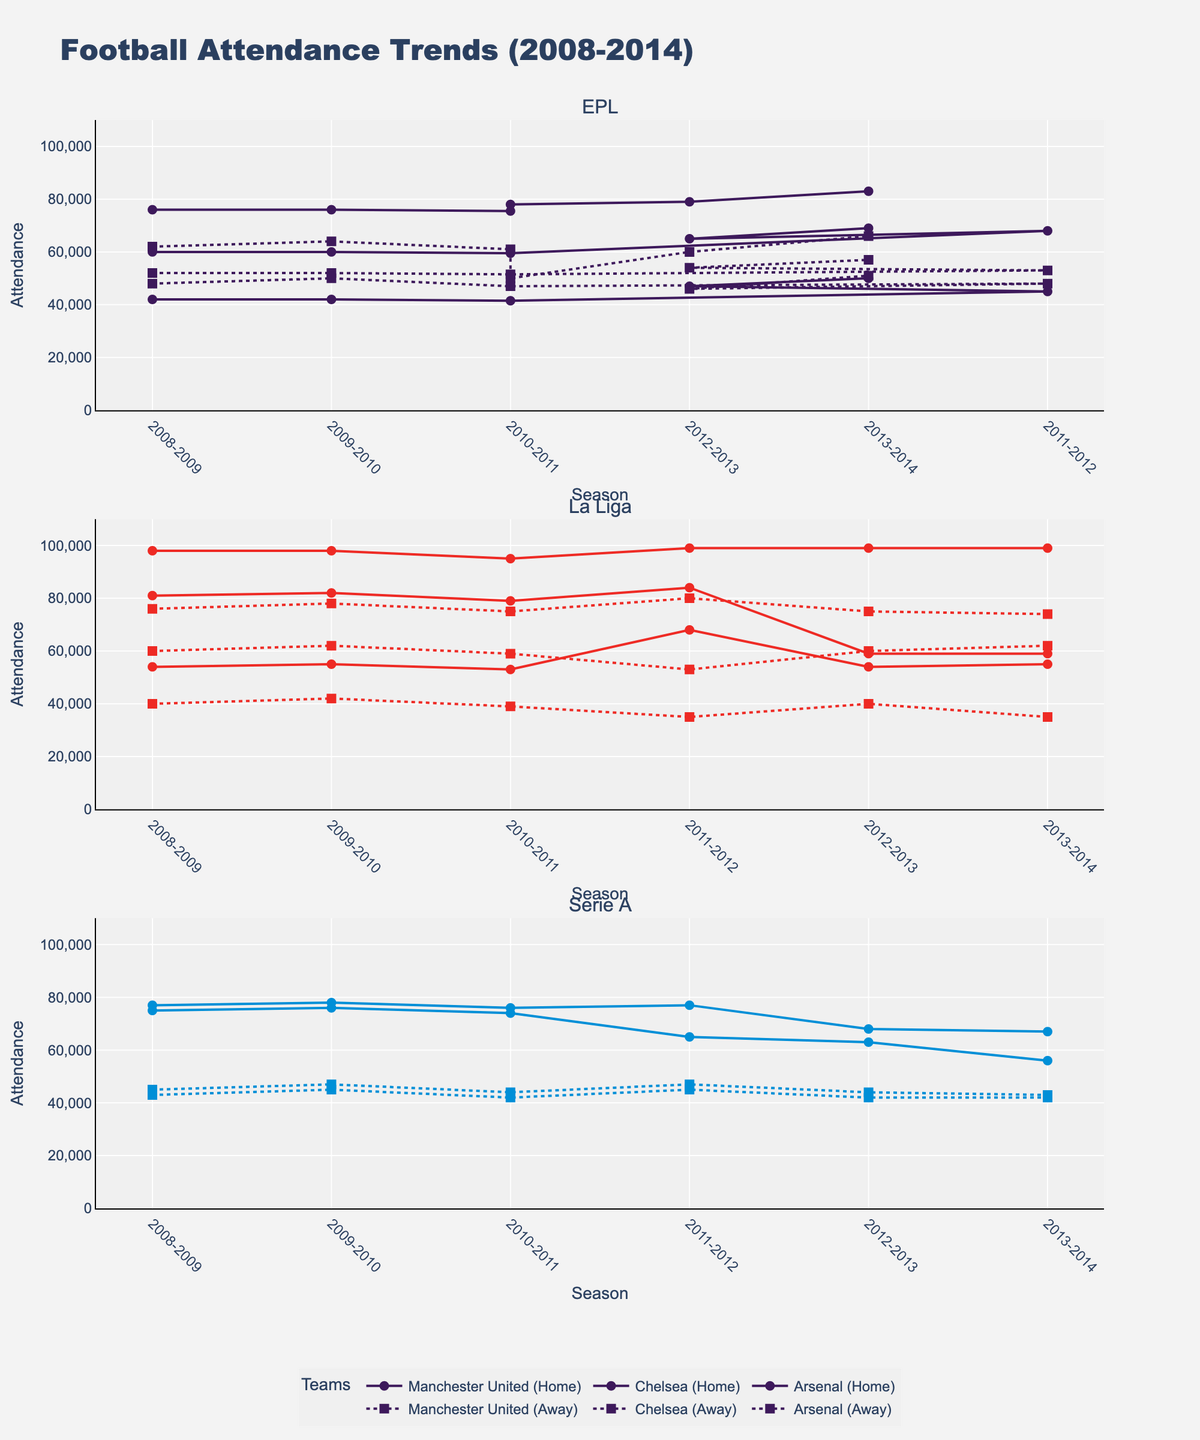What are the subplot titles in the figure? The subplot titles represent the three major European football leagues shown in the plot. They are the English Premier League (EPL), La Liga, and Serie A. Each subplot displays data specific to one league.
Answer: EPL, La Liga, Serie A What is the overall title of the figure? The overall title gives a general idea of what the figure is about, describing the trends in football attendance over the given period and for the specified leagues.
Answer: Football Attendance Trends (2008-2014) Which team had the highest home attendance in the 2011-2012 season for La Liga? By focusing on the La Liga subplot and looking at the year 2011-2012, identify which team's home attendance line peaks the highest out of all the La Liga teams. Barcelona has the highest home attendance.
Answer: Barcelona How did the away attendance of Manchester United change from the 2008-2009 season to the 2013-2014 season? Manchester United (Away) is represented by a line with markers in the EPL subplot. Comparing the away attendance markers for the 2008-2009 and 2013-2014 seasons, we see that it increased from 62000 to 66000.
Answer: Increased Which Serie A team showed a significant decrease in home attendance between 2011-2012 and 2013-2014? In the Serie A subplot, compare the home attendance lines for each team between the 2011-2012 and 2013-2014 seasons. Inter Milan shows a significant drop from 65000 to 56000.
Answer: Inter Milan What is the average home attendance for Chelsea across the seasons shown? In the EPL subplot, locate the home attendance points for Chelsea across the seasons and calculate the average: (42000 + 42000 + 41500 + 45000 + 47000 + 50000) / 6 = 44583.33
Answer: 44583.33 Which league has the most variation in home attendance among its teams? By observing the range and spread of home attendance markers in each subplot, La Liga shows the most variation with some teams having very high attendance (Barcelona) and others much lower (Atletico Madrid).
Answer: La Liga Did any team have consistent home attendance across all seasons? Checking each team's home attendance lines across all seasons for consistency. Manchester United in the EPL subplot maintains quite steady home attendance throughout the seasons.
Answer: Manchester United Which team has the smallest difference between home and away attendance in the 2012-2013 season in Serie A? In the Serie A subplot, compare the home and away attendance differences for each team in the 2012-2013 season. AC Milan has the smallest difference, with home attendance of 68000 and away attendance of 44000, a difference of 24000.
Answer: AC Milan 